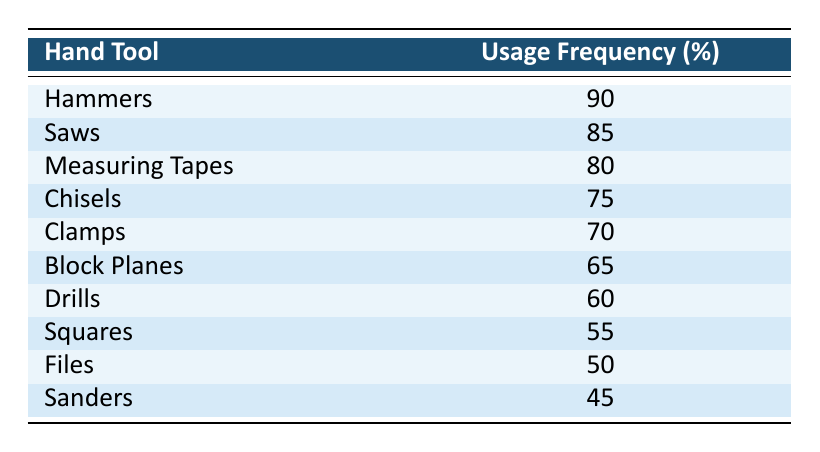What is the usage frequency of Hammers? The table clearly shows that Hammers have a usage frequency of 90%.
Answer: 90% Which hand tool has the second-highest usage frequency? Looking at the table, the second-highest usage frequency is for Saws with 85%.
Answer: Saws Is the usage frequency of Clamps higher than 75%? By referring to the table, Clamps have a usage frequency of 70%, which is lower than 75%.
Answer: No What is the average usage frequency of the tools listed in the table? To find the average, sum all the usage frequencies: (90 + 85 + 80 + 75 + 70 + 65 + 60 + 55 + 50 + 45) = 825. Then divide by the number of tools, which is 10: 825/10 = 82.5.
Answer: 82.5 Which tool has the lowest usage frequency? By examining the table, Sanders have the lowest usage frequency of 45%.
Answer: Sanders If we combine the usage frequencies of Files and Sanders, what is the total? The usage frequency of Files is 50%, and Sanders is 45%. Summing these gives: 50 + 45 = 95%.
Answer: 95% Do more than 50% of the tools have a usage frequency of at least 70%? Checking the table, the tools with usage frequencies of at least 70% are Hammers, Saws, Measuring Tapes, Chisels, and Clamps (5 tools), which is more than half of the total of 10.
Answer: Yes How much higher is the usage frequency of Measuring Tapes compared to Squares? The usage frequency of Measuring Tapes is 80%, and for Squares, it is 55%. The difference is calculated as 80 - 55 = 25%.
Answer: 25% 